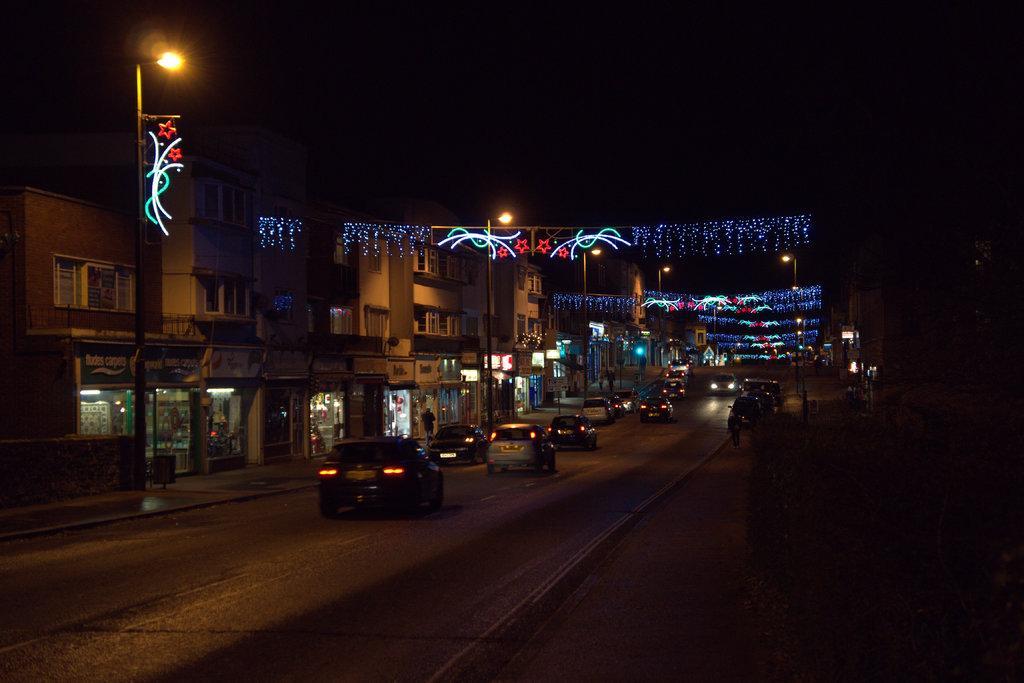Can you describe this image briefly? In this image we can see a group of buildings and vehicles. In the buildings we can see the stores. There are few street poles and lights in the middle of the image. 